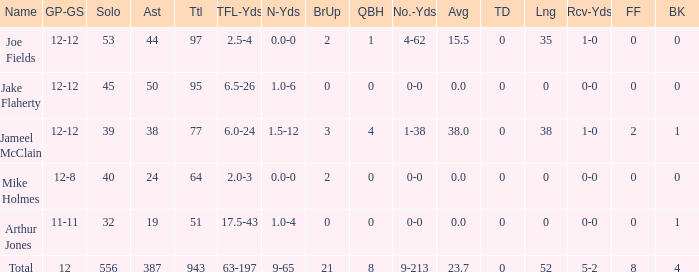How many yards for the player with tfl-yds of 2.5-4? 4-62. 